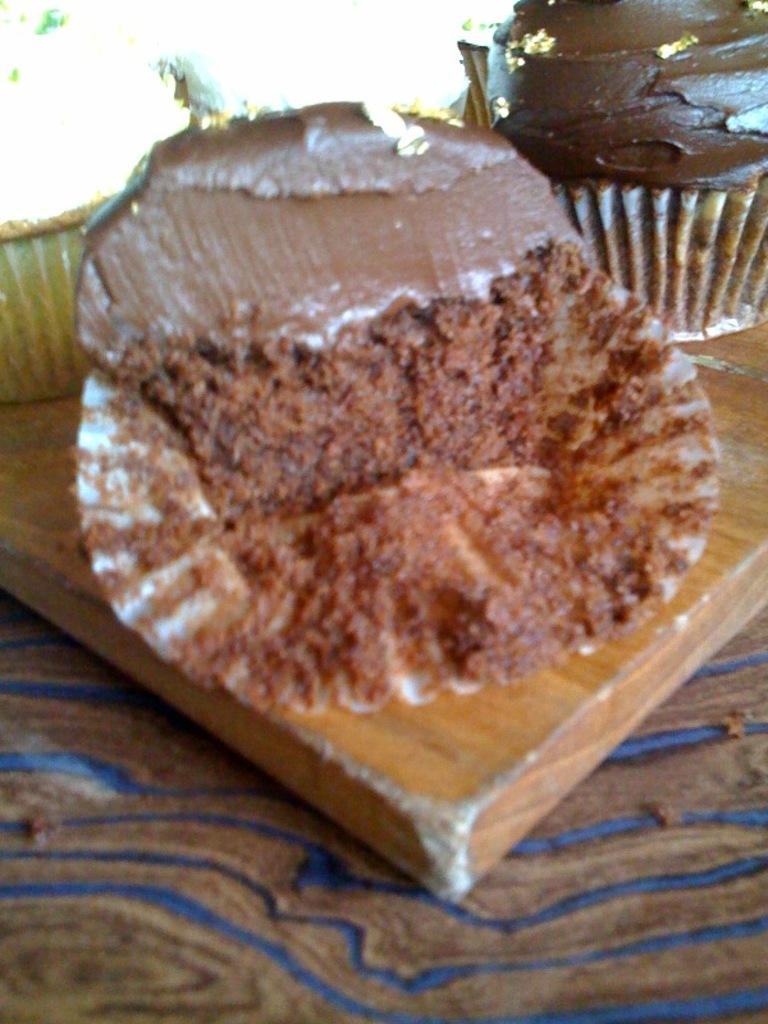What type of food is visible in the image? There are cupcakes in the image. What is the cupcakes resting on? The cupcakes are on a wooden object. How many kittens are playing with a string on the wooden object in the image? There are no kittens or string present in the image; it only features cupcakes on a wooden object. 